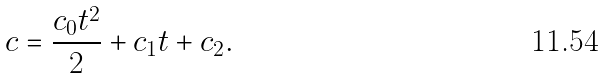<formula> <loc_0><loc_0><loc_500><loc_500>c = \frac { c _ { 0 } t ^ { 2 } } { 2 } + c _ { 1 } t + c _ { 2 } .</formula> 